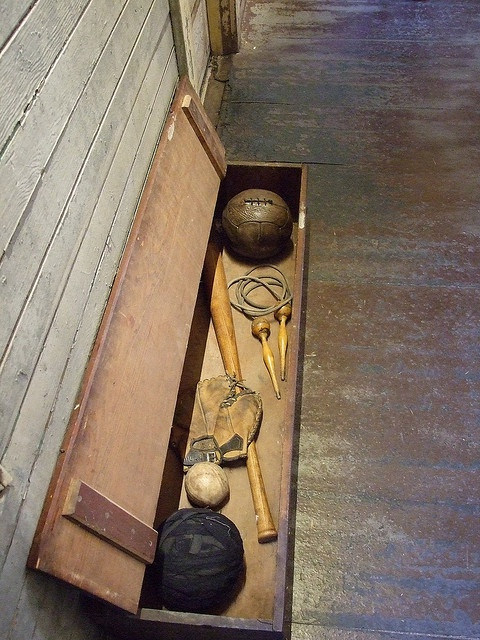Describe the objects in this image and their specific colors. I can see baseball bat in darkgray, tan, olive, and maroon tones, baseball glove in darkgray, tan, and olive tones, sports ball in darkgray, black, gray, and maroon tones, and sports ball in darkgray and tan tones in this image. 